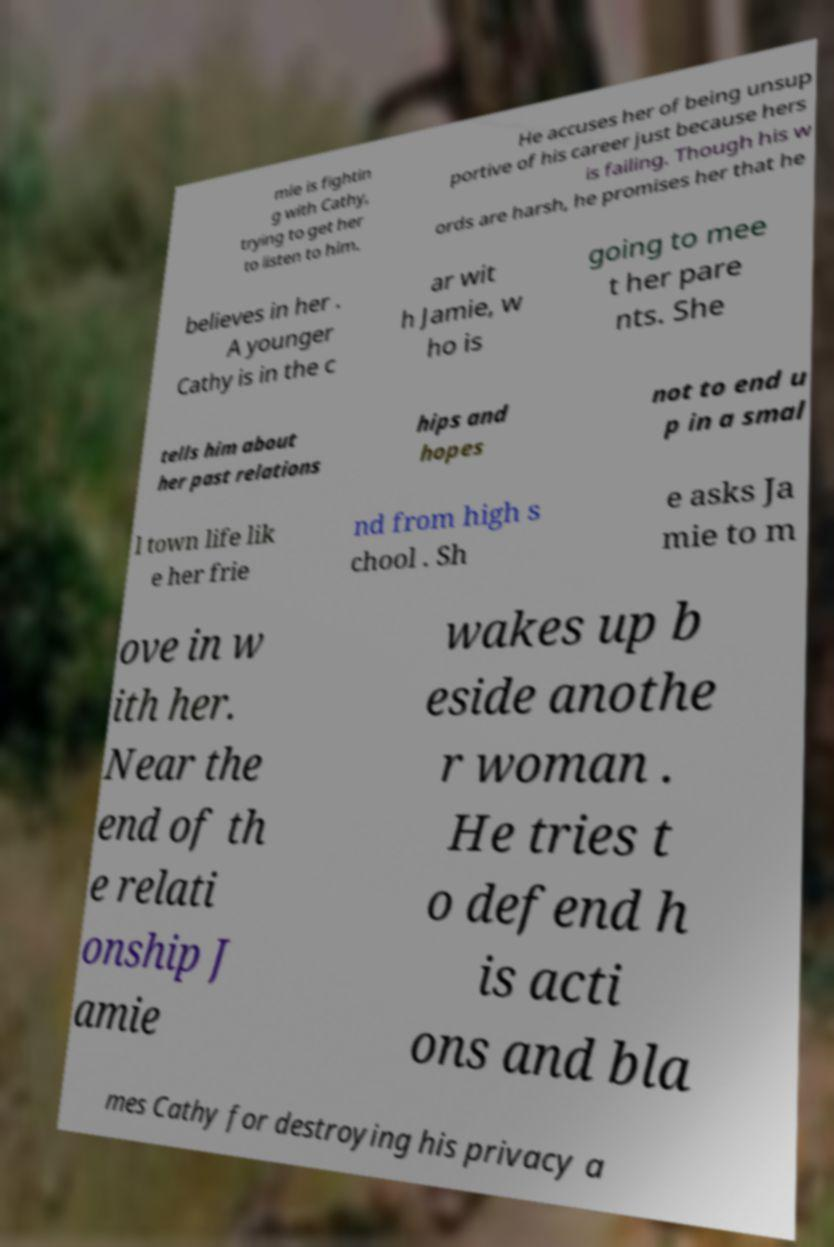For documentation purposes, I need the text within this image transcribed. Could you provide that? mie is fightin g with Cathy, trying to get her to listen to him. He accuses her of being unsup portive of his career just because hers is failing. Though his w ords are harsh, he promises her that he believes in her . A younger Cathy is in the c ar wit h Jamie, w ho is going to mee t her pare nts. She tells him about her past relations hips and hopes not to end u p in a smal l town life lik e her frie nd from high s chool . Sh e asks Ja mie to m ove in w ith her. Near the end of th e relati onship J amie wakes up b eside anothe r woman . He tries t o defend h is acti ons and bla mes Cathy for destroying his privacy a 